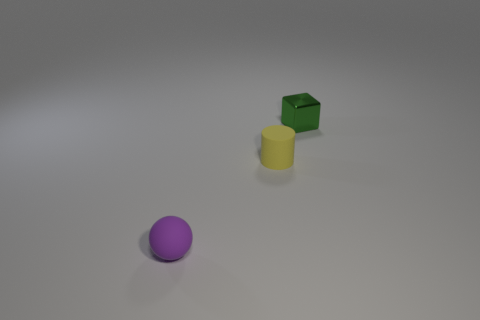There is a small matte thing left of the tiny matte object that is behind the small rubber sphere; how many rubber objects are behind it?
Provide a succinct answer. 1. There is a ball; is it the same size as the thing that is behind the yellow rubber cylinder?
Give a very brief answer. Yes. What is the size of the purple rubber ball in front of the small rubber thing on the right side of the rubber sphere?
Your answer should be very brief. Small. What number of green cubes are made of the same material as the small sphere?
Offer a very short reply. 0. Is there a green thing?
Offer a terse response. Yes. How big is the matte thing to the right of the purple matte ball?
Your answer should be very brief. Small. What number of cylinders are yellow rubber objects or rubber objects?
Your answer should be compact. 1. What is the shape of the object that is right of the tiny purple rubber sphere and in front of the green metal thing?
Ensure brevity in your answer.  Cylinder. Are there any purple rubber balls that have the same size as the green shiny object?
Offer a terse response. Yes. What number of objects are tiny rubber things that are behind the purple object or shiny spheres?
Your answer should be compact. 1. 